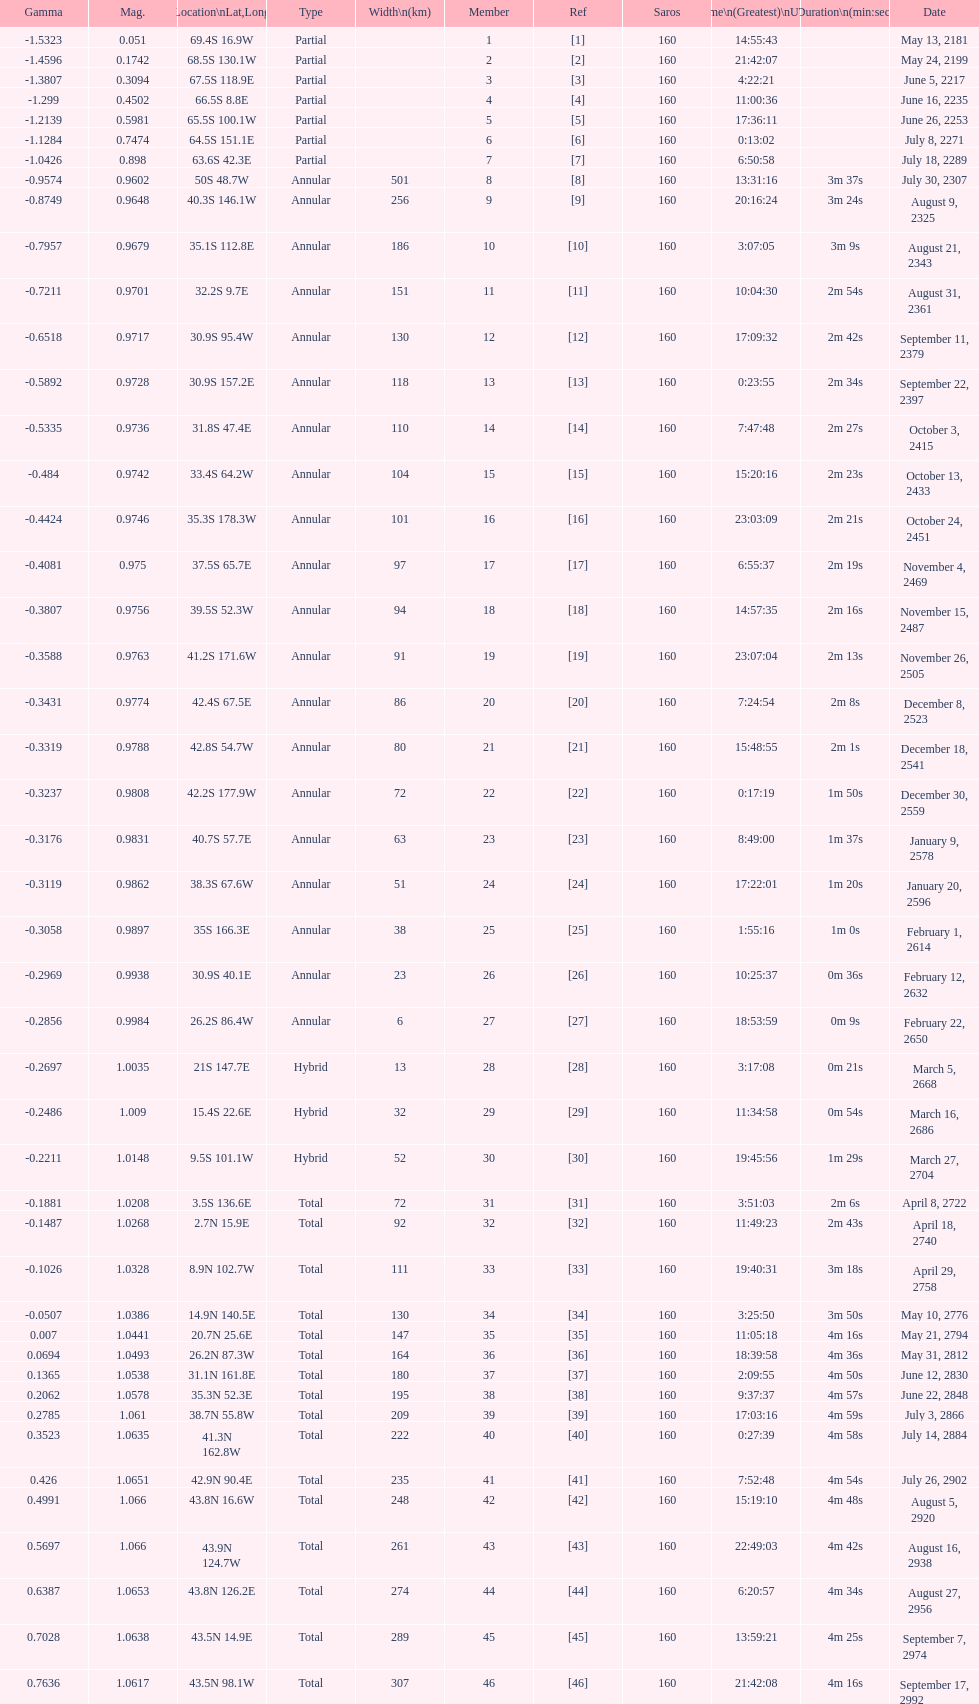Which one has a larger width, 8 or 21? 8. 